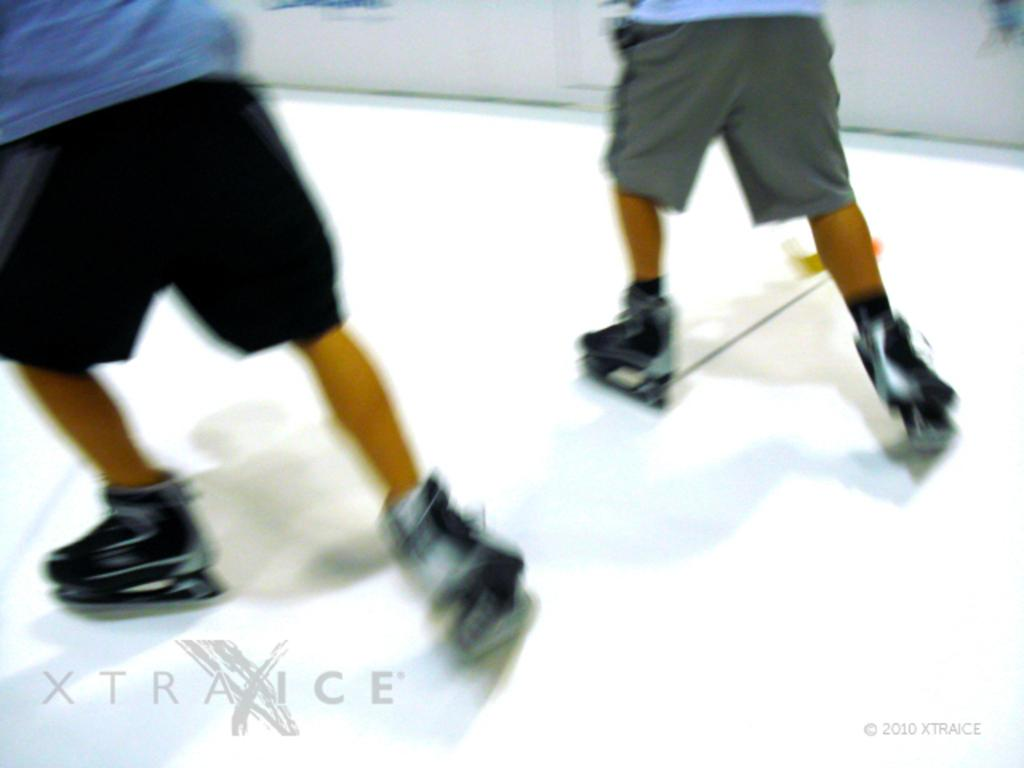How many people are in the image? There are two people in the image. What are the two people wearing on their feet? The two people are wearing roller skates. What is the position of the two people in the image? The two people are standing on the ground. What type of quartz can be seen in the image? There is no quartz present in the image. What time is displayed on the clocks in the image? There are no clocks present in the image. 